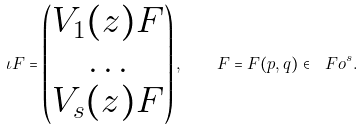<formula> <loc_0><loc_0><loc_500><loc_500>\iota F = \begin{pmatrix} V _ { 1 } ( z ) F \\ \dots \\ V _ { s } ( z ) F \\ \end{pmatrix} , \quad F = F ( p , q ) \in \ F o ^ { s } .</formula> 